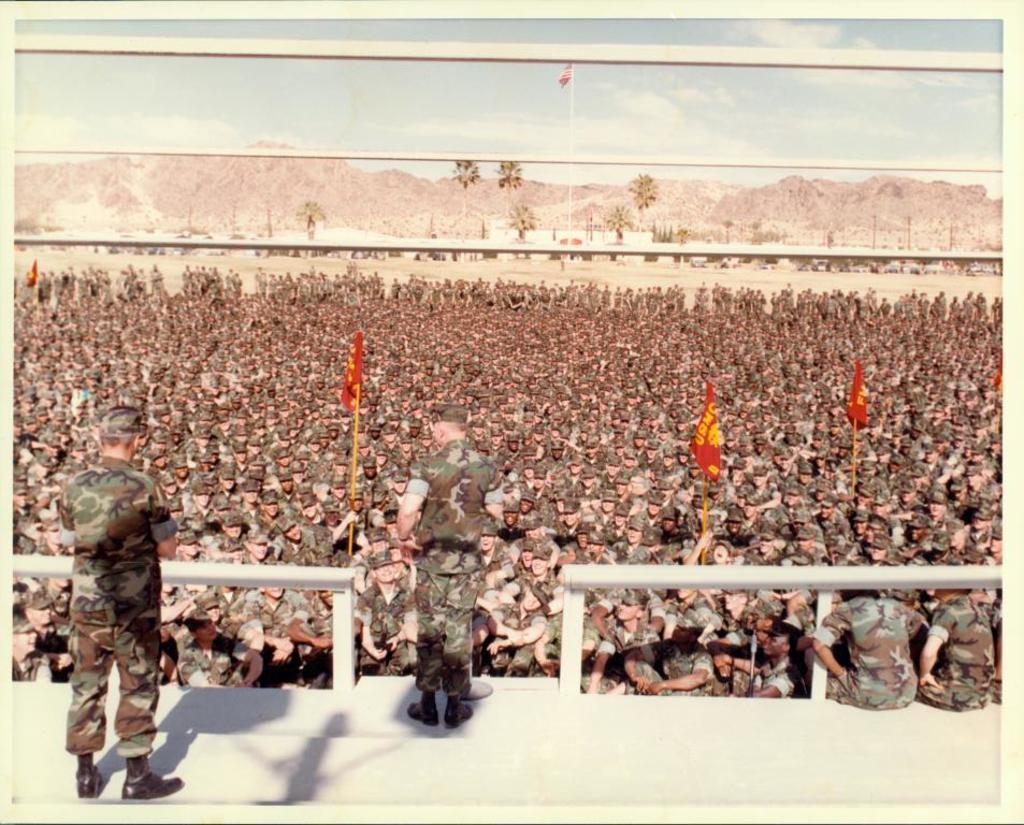How would you summarize this image in a sentence or two? In the picture there are a lot of army soldiers gathered in an area and in front of them two soldiers were standing on the dais and in the background there are many mountains and few trees. 